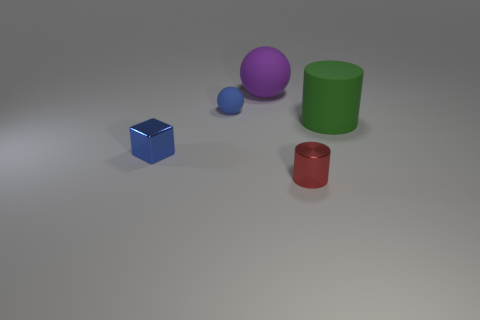Add 2 large brown cubes. How many objects exist? 7 Subtract 1 cylinders. How many cylinders are left? 1 Subtract all balls. How many objects are left? 3 Add 1 blue matte balls. How many blue matte balls exist? 2 Subtract 0 brown cylinders. How many objects are left? 5 Subtract all blue spheres. Subtract all blue cylinders. How many spheres are left? 1 Subtract all yellow spheres. How many red blocks are left? 0 Subtract all large metal balls. Subtract all tiny blue matte spheres. How many objects are left? 4 Add 3 blue matte balls. How many blue matte balls are left? 4 